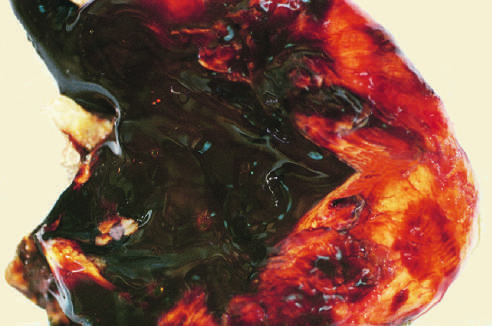does sectioning of ovary show a large endometriotic cyst with degenerated blood (chocolate cyst)?
Answer the question using a single word or phrase. Yes 